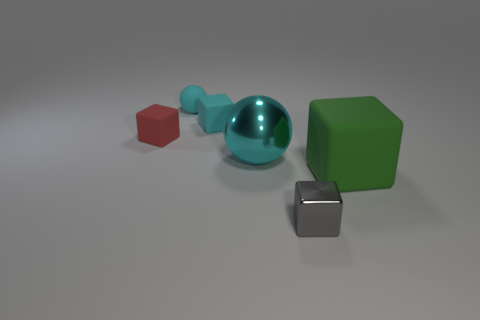Add 2 tiny red objects. How many objects exist? 8 Subtract all balls. How many objects are left? 4 Subtract 0 gray cylinders. How many objects are left? 6 Subtract all green objects. Subtract all purple rubber things. How many objects are left? 5 Add 1 cyan matte blocks. How many cyan matte blocks are left? 2 Add 4 gray shiny blocks. How many gray shiny blocks exist? 5 